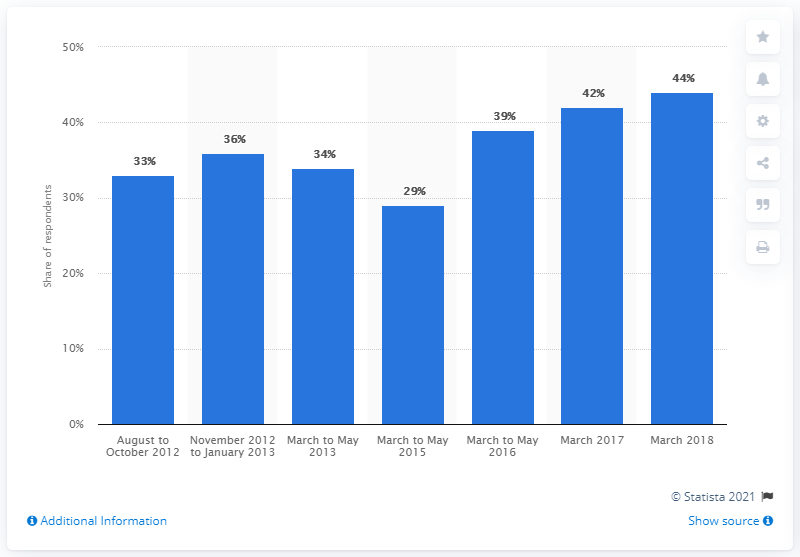Mention a couple of crucial points in this snapshot. The most recent survey wave ended in March 2018. 